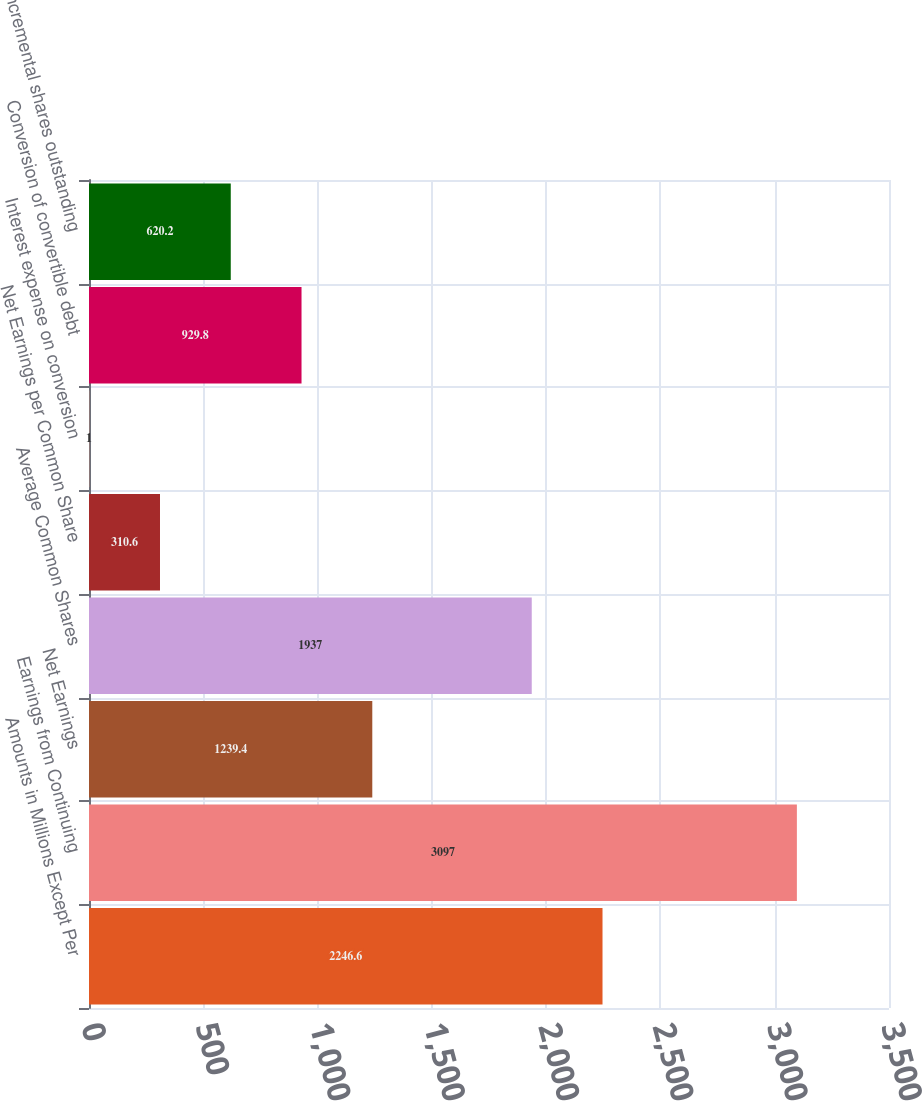Convert chart to OTSL. <chart><loc_0><loc_0><loc_500><loc_500><bar_chart><fcel>Amounts in Millions Except Per<fcel>Earnings from Continuing<fcel>Net Earnings<fcel>Average Common Shares<fcel>Net Earnings per Common Share<fcel>Interest expense on conversion<fcel>Conversion of convertible debt<fcel>Incremental shares outstanding<nl><fcel>2246.6<fcel>3097<fcel>1239.4<fcel>1937<fcel>310.6<fcel>1<fcel>929.8<fcel>620.2<nl></chart> 